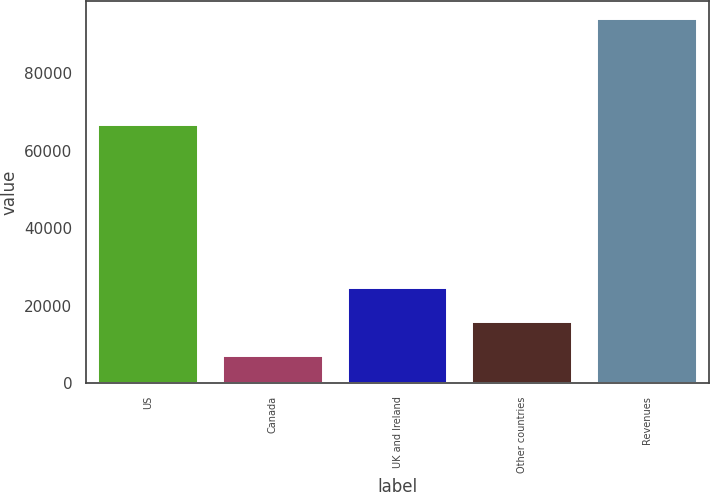Convert chart. <chart><loc_0><loc_0><loc_500><loc_500><bar_chart><fcel>US<fcel>Canada<fcel>UK and Ireland<fcel>Other countries<fcel>Revenues<nl><fcel>66614<fcel>7039<fcel>24427.2<fcel>15733.1<fcel>93980<nl></chart> 